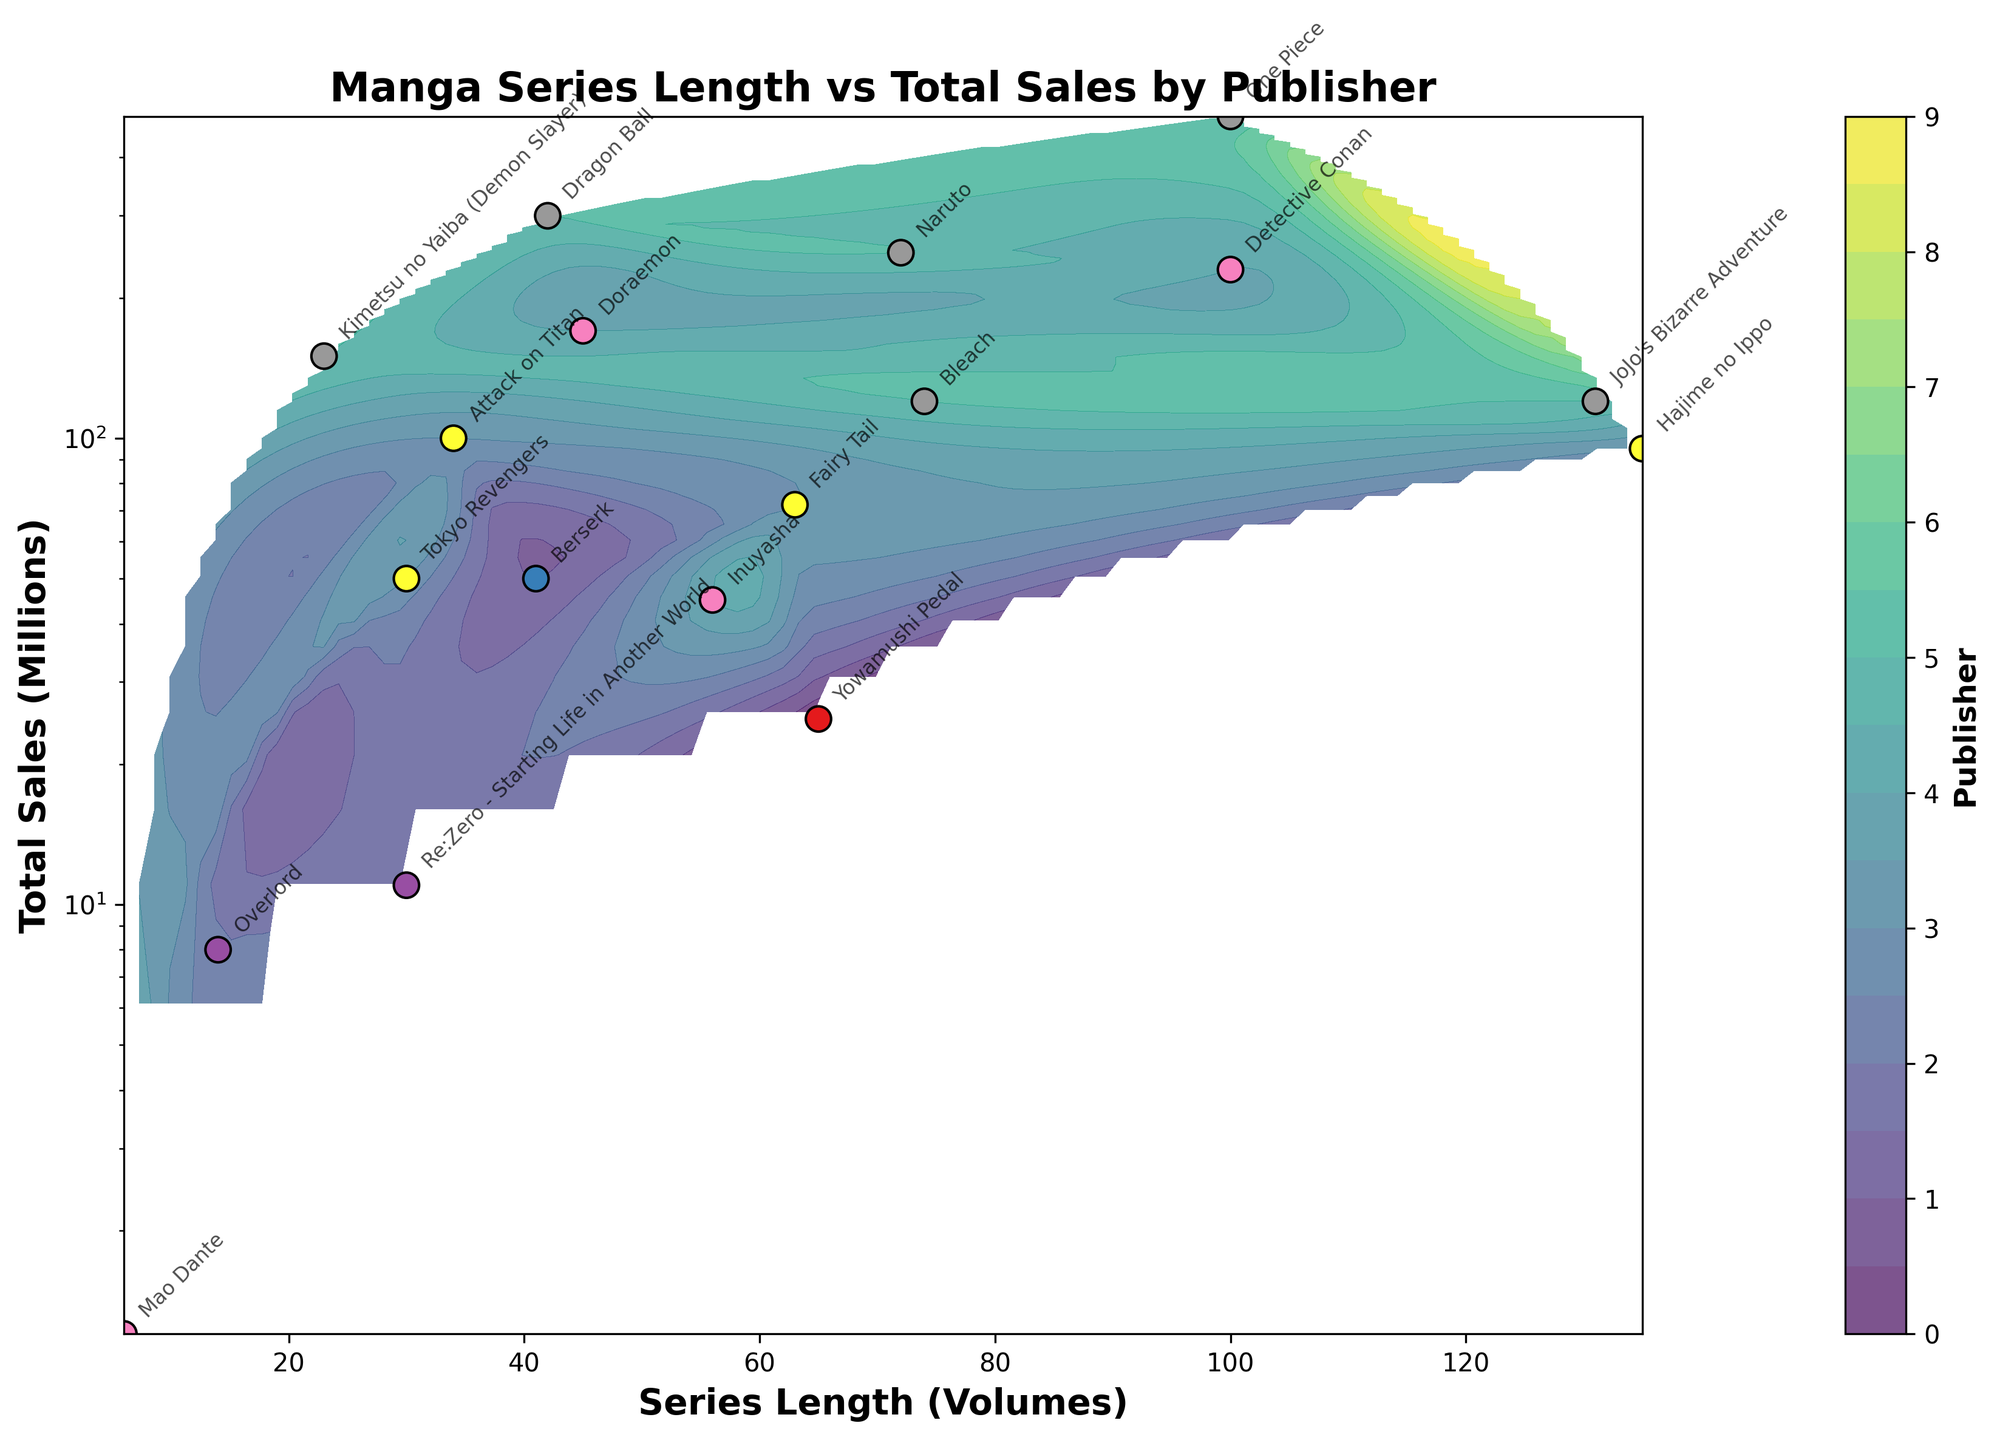what's the title of the figure? The title of the figure is usually displayed at the top in a larger, bold font. From the provided code, the title should be "Manga Series Length vs Total Sales by Publisher".
Answer: Manga Series Length vs Total Sales by Publisher how many manga series data points are shown? Each data point on a scatter plot represents one manga series. By counting the individual points labeled in the plot as per the provided data, we can determine the number. From the data, there are 17 manga series.
Answer: 17 which publisher has the manga series with the highest total sales? By looking at the total sales axis (y-axis), find the highest point and then refer to the publisher that corresponds to that point. The highest sales value is 490 million, for "Shueisha" with "One Piece".
Answer: Shueisha what's the range of the series length for Shogakukan's manga? Identify the data points that belong to "Shogakukan" and check their x-axis (series length) values. "Shogakukan" has series lengths of 45, 100, 56, and 6 volumes. The range is from 6 to 100.
Answer: 6 to 100 volumes which series has the lowest total sales and what is the publisher? Find the data point that is the lowest on the y-axis and check the corresponding series and publisher from the data labels. The lowest total sales is "Mao Dante" by "Shogakukan" with 1.2 million.
Answer: Mao Dante, Shogakukan what's the average total sales for manga series published by Shueisha? Identify the data points for Shueisha and sum their total sales, then divide by the number of Shueisha series. The series and their total sales are (One Piece: 490, Naruto: 250, Bleach: 120, Dragon Ball: 300, JoJo’s Bizarre Adventure: 120, Kimetsu no Yaiba: 150). Sum is 1430, divided by 6.
Answer: 238.33 million which series has longer series length: "Hajime no Ippo" or "Dragon Ball"? Compare the x-axis values for "Hajime no Ippo" and "Dragon Ball". "Hajime no Ippo" has 135 volumes, "Dragon Ball" has 42 volumes.
Answer: Hajime no Ippo how does the total sales of "Fairy Tail" compare to "Tokyo Revengers"? Compare the y-axis values for both manga series. "Fairy Tail" has 72 million, "Tokyo Revengers" has 50 million.
Answer: Fairy Tail is higher what's the contour color representation for data points of Kadokawa and compare their general position on the plot? Contour colors are coded to represent different publishers. Find the color assigned to Kadokawa, then evaluate their general distribution on the plot concerning series length and total sales. There are "Re:Zero" and "Overlord" in Kadokawa, find their relative positions.
Answer: Kadokawa series mainly lie in the shorter length and lower sales region how is the y-axis scaled on the figure and why might this have been done? The y-axis is set to a logarithmic scale for better visualization due to the wide range of sales data, which spans from as low as 1.2 million to 490 million. Using a logarithmic scale makes it easier to see differences and patterns across such a wide range.
Answer: Logarithmic scale, for better visualization of wide range of sales 